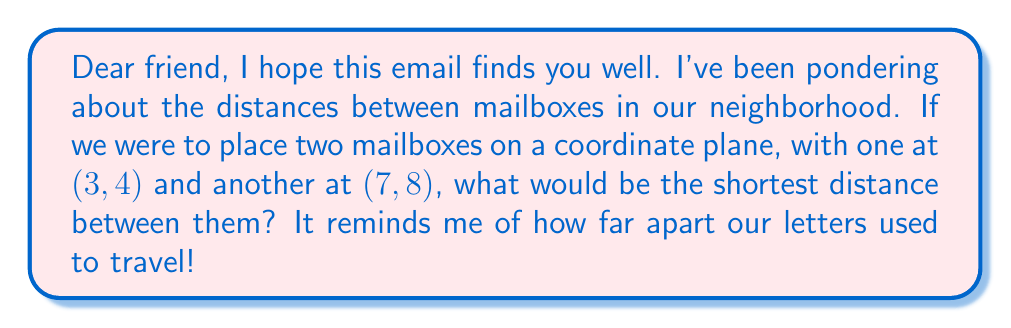Provide a solution to this math problem. To find the shortest distance between two points on a coordinate plane, we can use the distance formula, which is derived from the Pythagorean theorem. Let's approach this step-by-step:

1) The distance formula is:
   $$d = \sqrt{(x_2 - x_1)^2 + (y_2 - y_1)^2}$$
   where $(x_1, y_1)$ is the first point and $(x_2, y_2)$ is the second point.

2) In our case:
   $(x_1, y_1) = (3, 4)$ and $(x_2, y_2) = (7, 8)$

3) Let's substitute these values into the formula:
   $$d = \sqrt{(7 - 3)^2 + (8 - 4)^2}$$

4) Simplify inside the parentheses:
   $$d = \sqrt{4^2 + 4^2}$$

5) Calculate the squares:
   $$d = \sqrt{16 + 16}$$

6) Add inside the square root:
   $$d = \sqrt{32}$$

7) Simplify the square root:
   $$d = 4\sqrt{2}$$

This is the exact value. If we wanted to express it as a decimal, we could calculate:
   $$d \approx 5.66$$ (rounded to two decimal places)

[asy]
unitsize(1cm);
draw((-1,-1)--(9,9), gray);
draw((-1,9)--(9,-1), gray);
for(int i=-1; i<=9; ++i) {
  draw((i,-0.2)--(i,0.2), gray);
  draw((-0.2,i)--(0.2,i), gray);
}
dot((3,4));
dot((7,8));
draw((3,4)--(7,8), red);
label("(3,4)", (3,4), SW);
label("(7,8)", (7,8), NE);
label("d", ((5,6)), SE, red);
[/asy]
Answer: $4\sqrt{2}$ units 